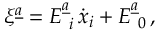Convert formula to latex. <formula><loc_0><loc_0><loc_500><loc_500>\xi ^ { \underline { a } } = E _ { \ i } ^ { \underline { a } } \, \dot { x } _ { i } + E _ { \ 0 } ^ { \underline { a } } \, ,</formula> 